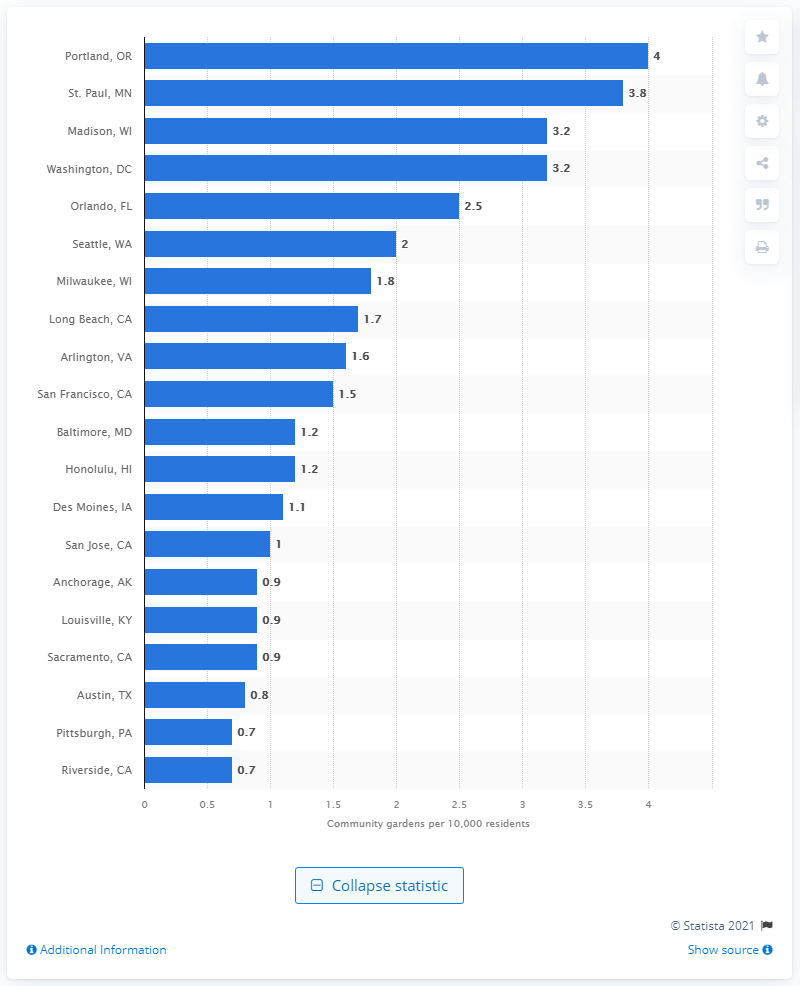Mention a couple of crucial points in this snapshot. Portland, Oregon had the highest density of community gardens in 2020. 